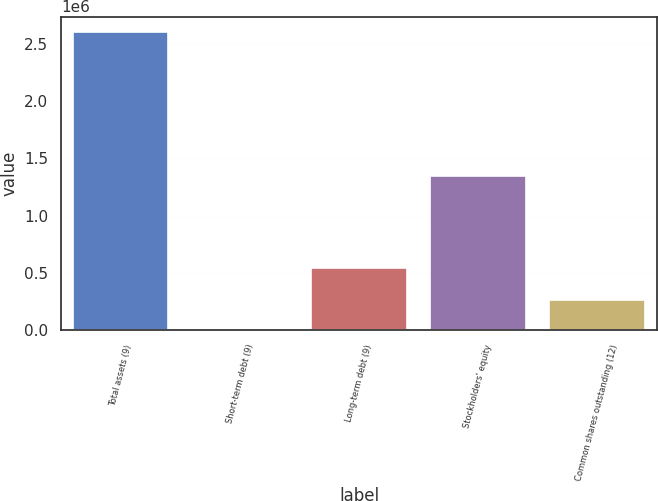Convert chart. <chart><loc_0><loc_0><loc_500><loc_500><bar_chart><fcel>Total assets (9)<fcel>Short-term debt (9)<fcel>Long-term debt (9)<fcel>Stockholders' equity<fcel>Common shares outstanding (12)<nl><fcel>2.60773e+06<fcel>5167<fcel>544307<fcel>1.34905e+06<fcel>265423<nl></chart> 